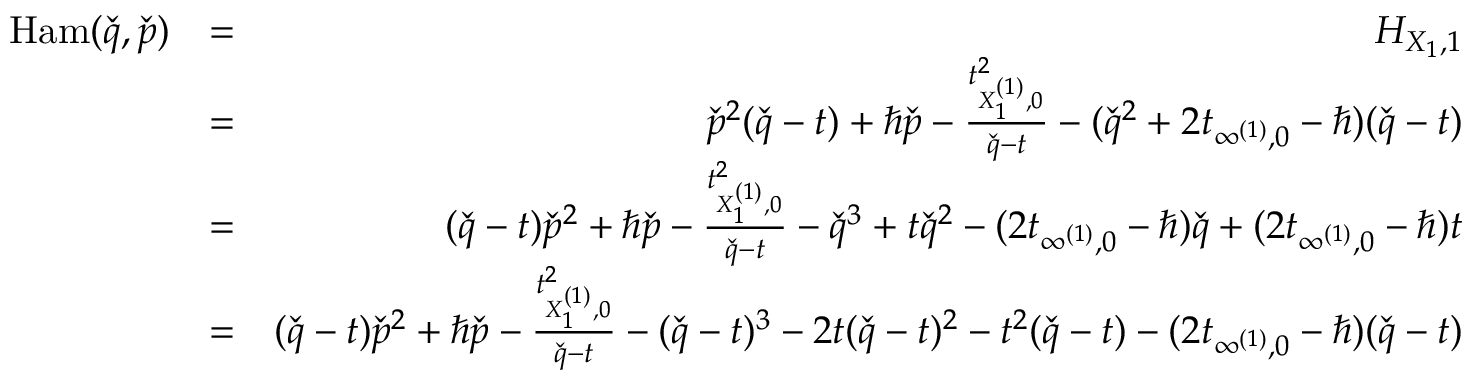Convert formula to latex. <formula><loc_0><loc_0><loc_500><loc_500>\begin{array} { r l r } { H a m ( \check { q } , \check { p } ) } & { = } & { H _ { X _ { 1 } , 1 } } \\ & { = } & { \check { p } ^ { 2 } ( \check { q } - t ) + \hbar { \check } { p } - \frac { t _ { X _ { 1 } ^ { ( 1 ) } , 0 } ^ { 2 } } { \check { q } - t } - ( \check { q } ^ { 2 } + 2 t _ { \infty ^ { ( 1 ) } , 0 } - \hbar { ) } ( \check { q } - t ) } \\ & { = } & { ( \check { q } - t ) \check { p } ^ { 2 } + \hbar { \check } { p } - \frac { t _ { X _ { 1 } ^ { ( 1 ) } , 0 } ^ { 2 } } { \check { q } - t } - \check { q } ^ { 3 } + t \check { q } ^ { 2 } - ( 2 t _ { \infty ^ { ( 1 ) } , 0 } - \hbar { ) } \check { q } + ( 2 t _ { \infty ^ { ( 1 ) } , 0 } - \hbar { ) } t } \\ & { = } & { ( \check { q } - t ) \check { p } ^ { 2 } + \hbar { \check } { p } - \frac { t _ { X _ { 1 } ^ { ( 1 ) } , 0 } ^ { 2 } } { \check { q } - t } - ( \check { q } - t ) ^ { 3 } - 2 t ( \check { q } - t ) ^ { 2 } - t ^ { 2 } ( \check { q } - t ) - ( 2 t _ { \infty ^ { ( 1 ) } , 0 } - \hbar { ) } ( \check { q } - t ) } \\ & \end{array}</formula> 